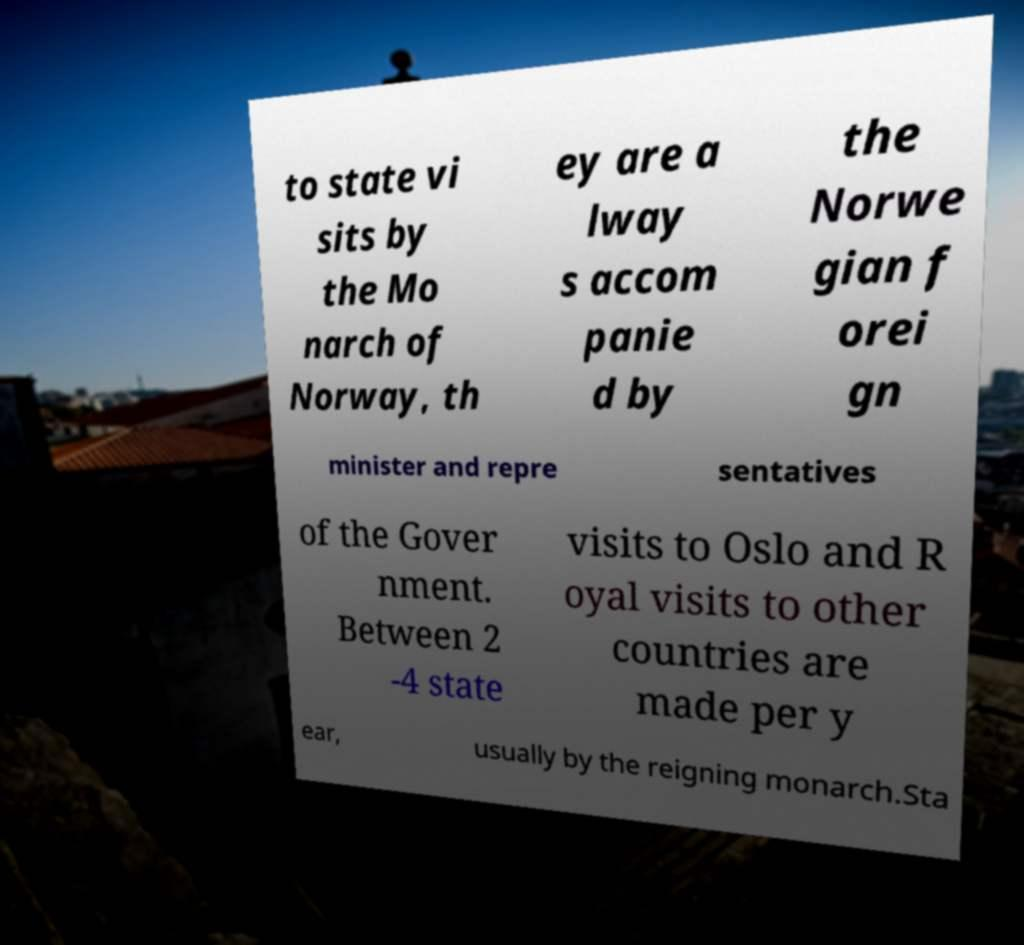For documentation purposes, I need the text within this image transcribed. Could you provide that? to state vi sits by the Mo narch of Norway, th ey are a lway s accom panie d by the Norwe gian f orei gn minister and repre sentatives of the Gover nment. Between 2 -4 state visits to Oslo and R oyal visits to other countries are made per y ear, usually by the reigning monarch.Sta 